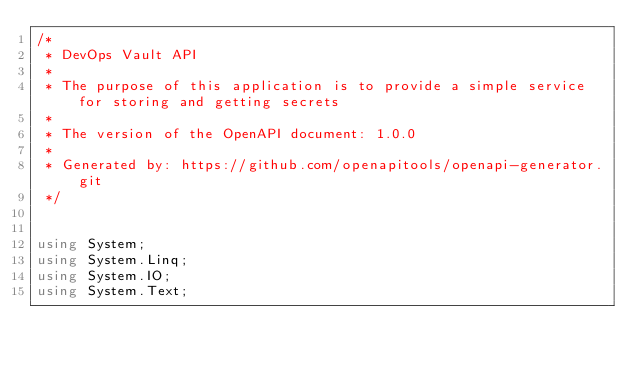<code> <loc_0><loc_0><loc_500><loc_500><_C#_>/* 
 * DevOps Vault API
 *
 * The purpose of this application is to provide a simple service for storing and getting secrets
 *
 * The version of the OpenAPI document: 1.0.0
 * 
 * Generated by: https://github.com/openapitools/openapi-generator.git
 */


using System;
using System.Linq;
using System.IO;
using System.Text;</code> 